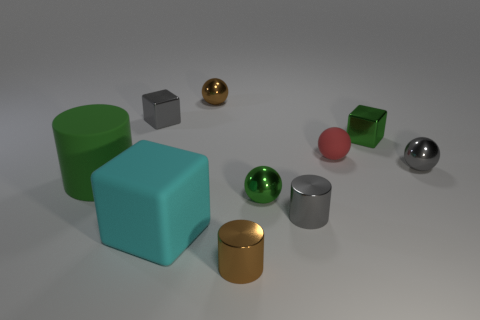Subtract all cubes. How many objects are left? 7 Subtract 1 green blocks. How many objects are left? 9 Subtract all small gray balls. Subtract all small green things. How many objects are left? 7 Add 6 big cyan cubes. How many big cyan cubes are left? 7 Add 9 big yellow rubber things. How many big yellow rubber things exist? 9 